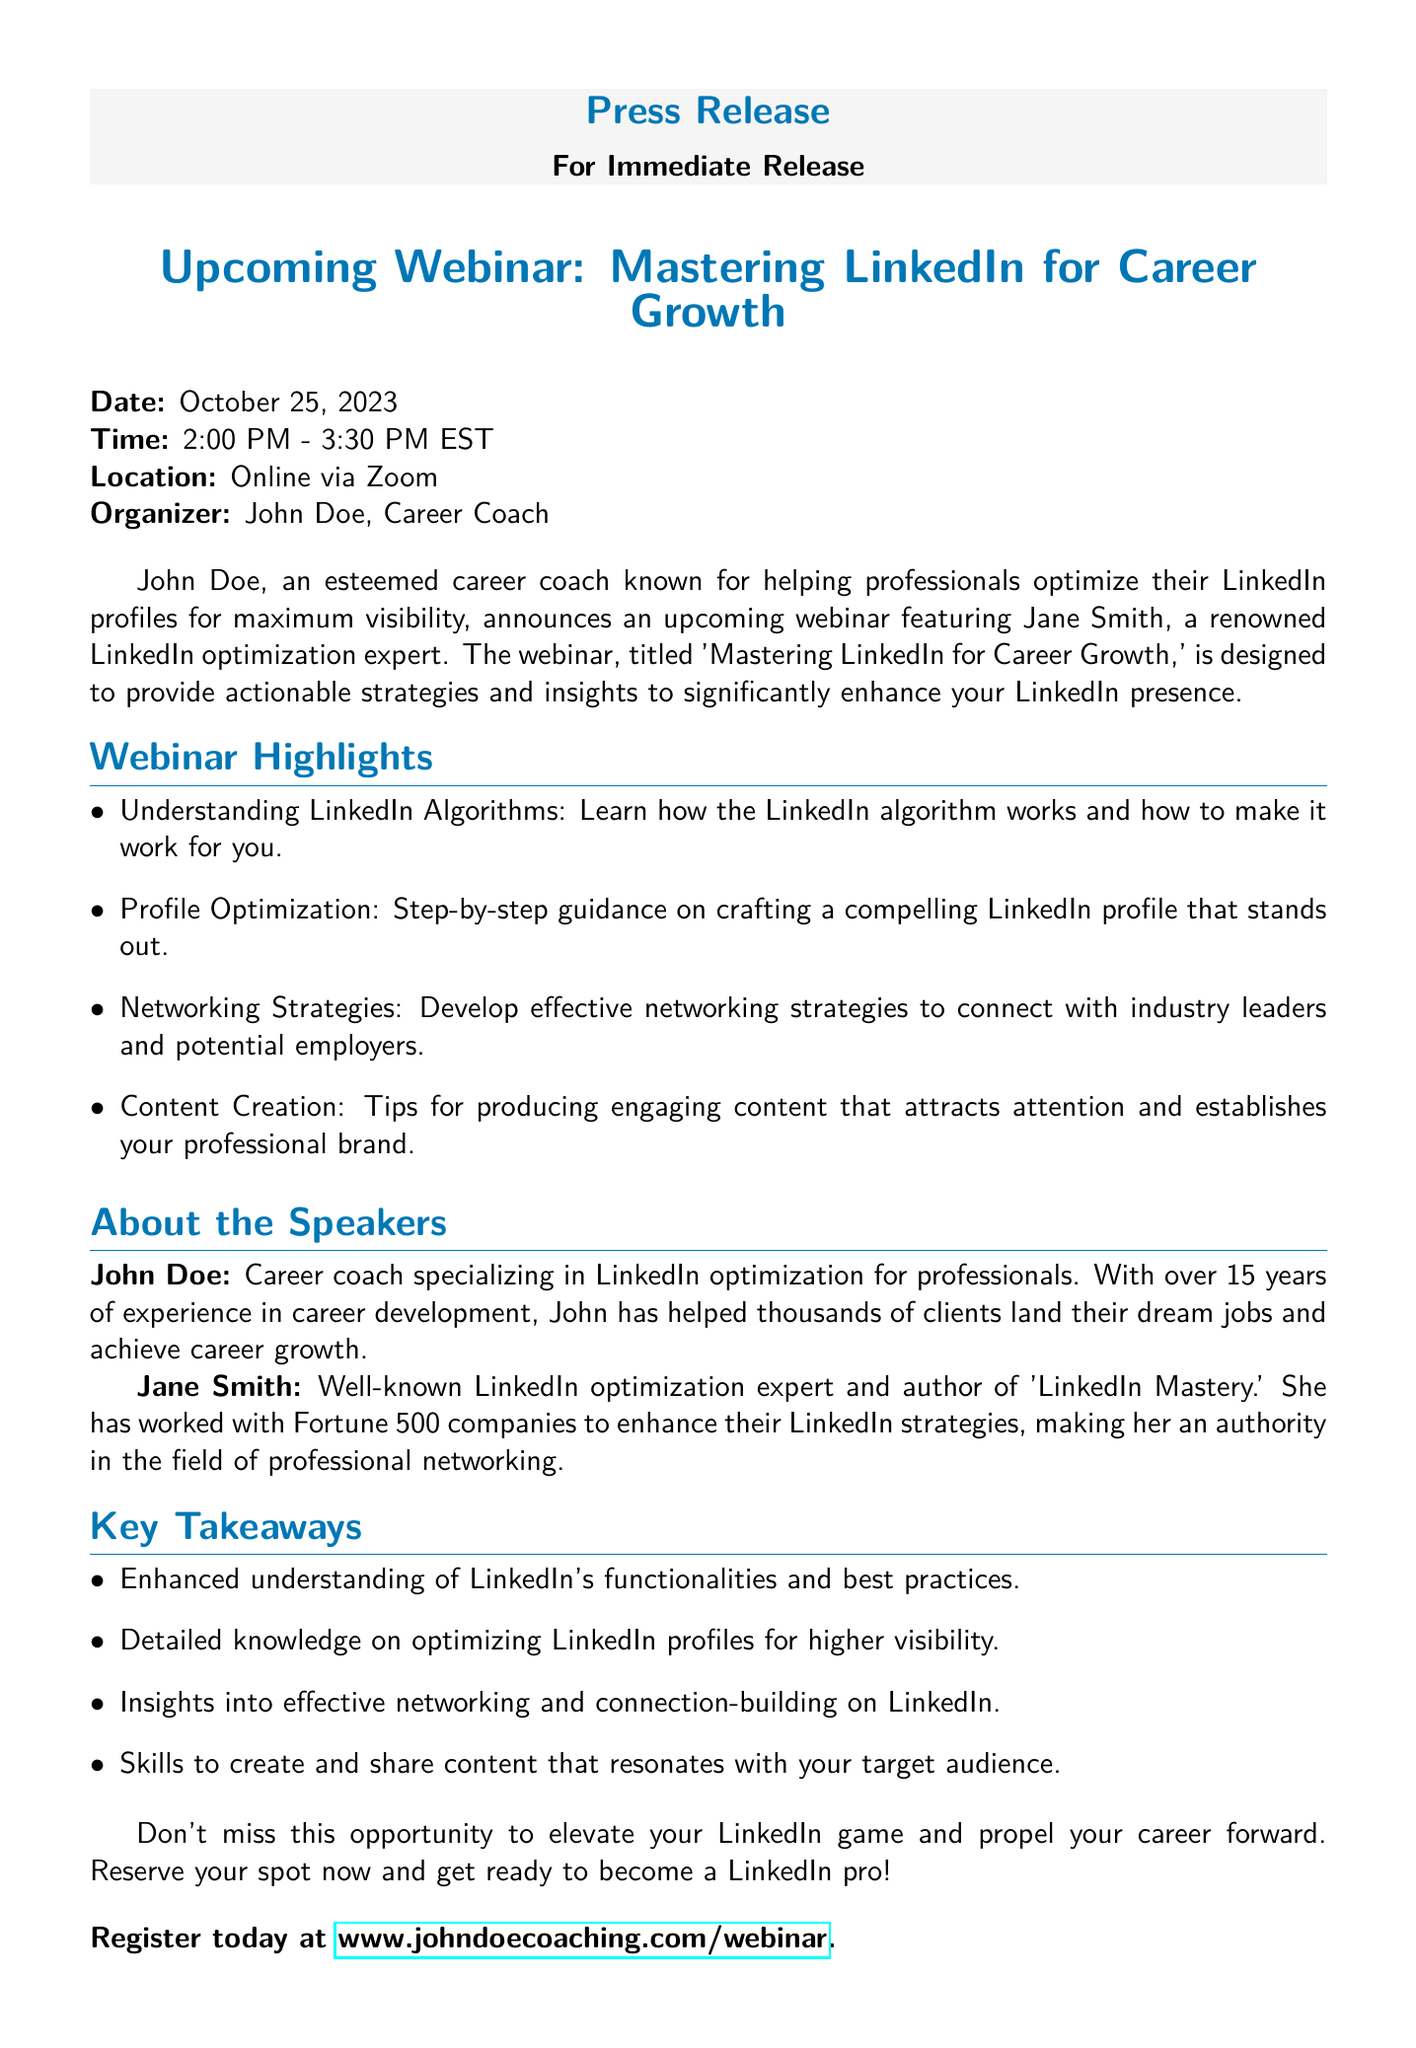What is the date of the webinar? The date of the webinar is explicitly stated in the document as October 25, 2023.
Answer: October 25, 2023 What time does the webinar start? The starting time is mentioned as 2:00 PM - 3:30 PM EST in the document.
Answer: 2:00 PM - 3:30 PM EST Who is the organizer of the webinar? The organizer mentioned in the document is John Doe, indicating his role in the event.
Answer: John Doe What is the title of the webinar? The title of the webinar is presented as 'Mastering LinkedIn for Career Growth' in the document.
Answer: Mastering LinkedIn for Career Growth What is one topic highlighted in the webinar? The webinar highlights several topics, one of which is understanding LinkedIn algorithms, as stated in the document.
Answer: Understanding LinkedIn Algorithms How long has John Doe been a career coach? The document states that John Doe has over 15 years of experience in career development.
Answer: Over 15 years Who is a speaker at the webinar? The document lists Jane Smith as one of the speakers at the webinar.
Answer: Jane Smith What is one of the key takeaways from the webinar? The document lists several key takeaways, one of which is enhanced understanding of LinkedIn's functionalities.
Answer: Enhanced understanding of LinkedIn's functionalities What is the registration URL for the webinar? The registration URL is explicitly provided in the document as www.johndoecoaching.com/webinar.
Answer: www.johndoecoaching.com/webinar 